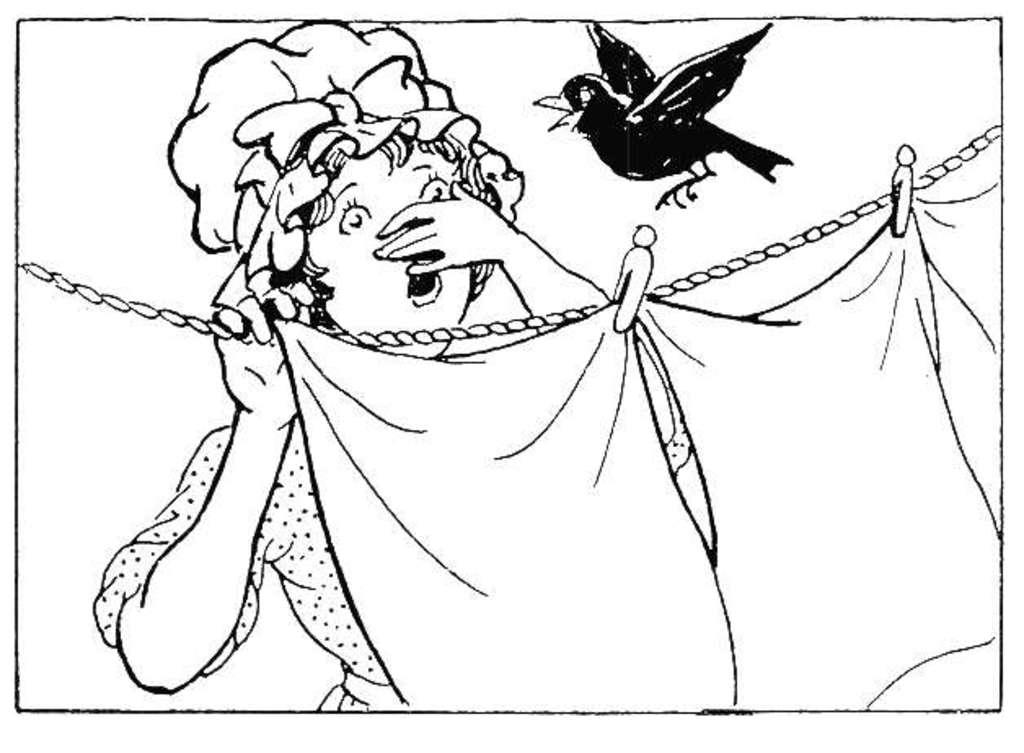What is depicted in the image? There is a drawing of a person in the image. What else can be seen in the image besides the drawing? Clothes are hanging on a rope in the image, and there are clips visible as well. Are there any living creatures in the image? Yes, there is a bird in the image. What type of event is taking place in the image? There is no event depicted in the image; it is a static scene featuring a drawing, clothes hanging on a rope, clips, and a bird. How does the bird adjust its feathers in the image? The image does not show the bird adjusting its feathers; it is simply depicted as a static image. 